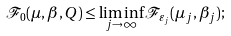<formula> <loc_0><loc_0><loc_500><loc_500>\mathcal { F } _ { 0 } ( \mu , \beta , Q ) \leq \liminf _ { j \to \infty } \mathcal { F } _ { \varepsilon _ { j } } ( \mu _ { j } , \beta _ { j } ) ;</formula> 